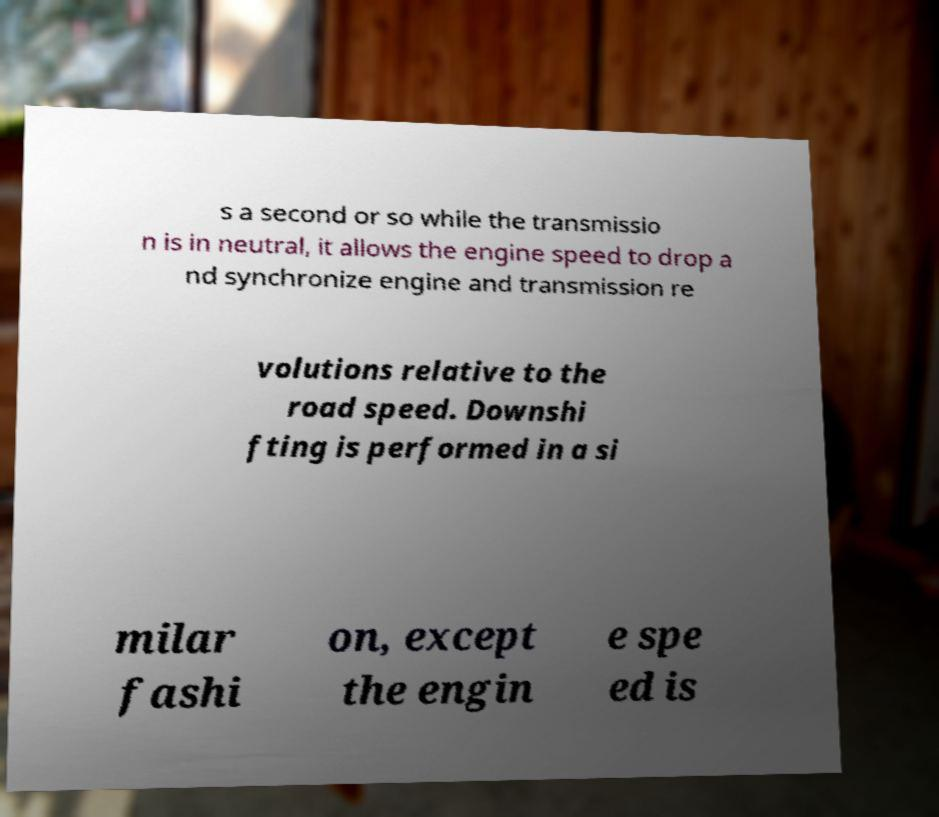What messages or text are displayed in this image? I need them in a readable, typed format. s a second or so while the transmissio n is in neutral, it allows the engine speed to drop a nd synchronize engine and transmission re volutions relative to the road speed. Downshi fting is performed in a si milar fashi on, except the engin e spe ed is 